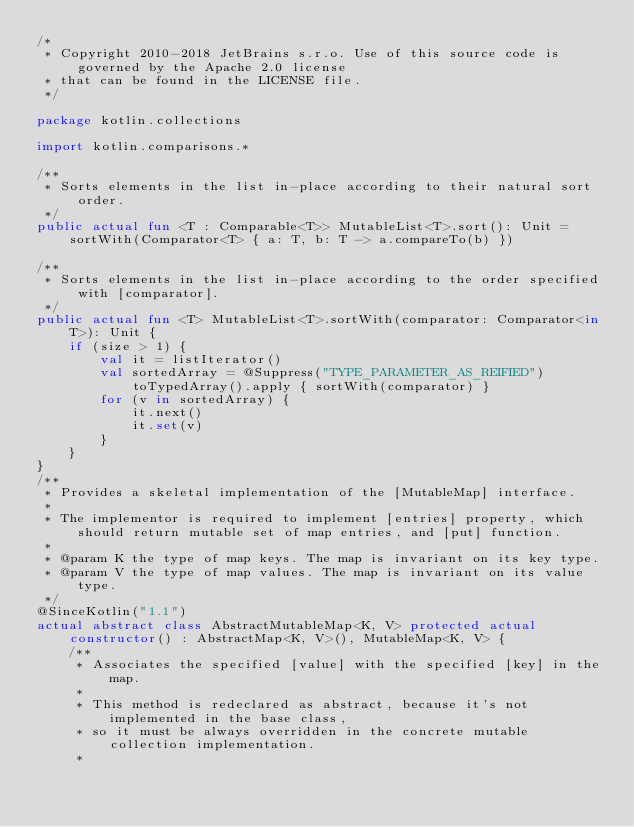Convert code to text. <code><loc_0><loc_0><loc_500><loc_500><_Kotlin_>/*
 * Copyright 2010-2018 JetBrains s.r.o. Use of this source code is governed by the Apache 2.0 license
 * that can be found in the LICENSE file.
 */

package kotlin.collections

import kotlin.comparisons.*

/**
 * Sorts elements in the list in-place according to their natural sort order.
 */
public actual fun <T : Comparable<T>> MutableList<T>.sort(): Unit = sortWith(Comparator<T> { a: T, b: T -> a.compareTo(b) })

/**
 * Sorts elements in the list in-place according to the order specified with [comparator].
 */
public actual fun <T> MutableList<T>.sortWith(comparator: Comparator<in T>): Unit {
    if (size > 1) {
        val it = listIterator()
        val sortedArray = @Suppress("TYPE_PARAMETER_AS_REIFIED") toTypedArray().apply { sortWith(comparator) }
        for (v in sortedArray) {
            it.next()
            it.set(v)
        }
    }
}
/**
 * Provides a skeletal implementation of the [MutableMap] interface.
 *
 * The implementor is required to implement [entries] property, which should return mutable set of map entries, and [put] function.
 *
 * @param K the type of map keys. The map is invariant on its key type.
 * @param V the type of map values. The map is invariant on its value type.
 */
@SinceKotlin("1.1")
actual abstract class AbstractMutableMap<K, V> protected actual constructor() : AbstractMap<K, V>(), MutableMap<K, V> {
    /**
     * Associates the specified [value] with the specified [key] in the map.
     *
     * This method is redeclared as abstract, because it's not implemented in the base class,
     * so it must be always overridden in the concrete mutable collection implementation.
     *</code> 